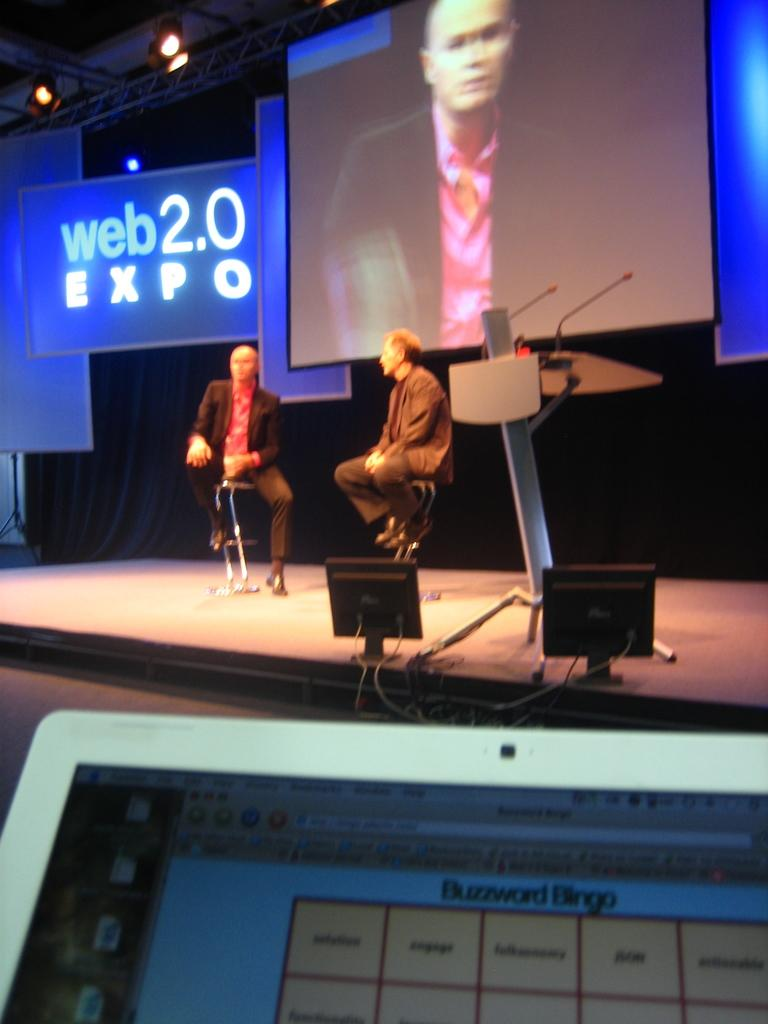<image>
Present a compact description of the photo's key features. Two men sit on a stage and converse during a web 2.0 Expo. 